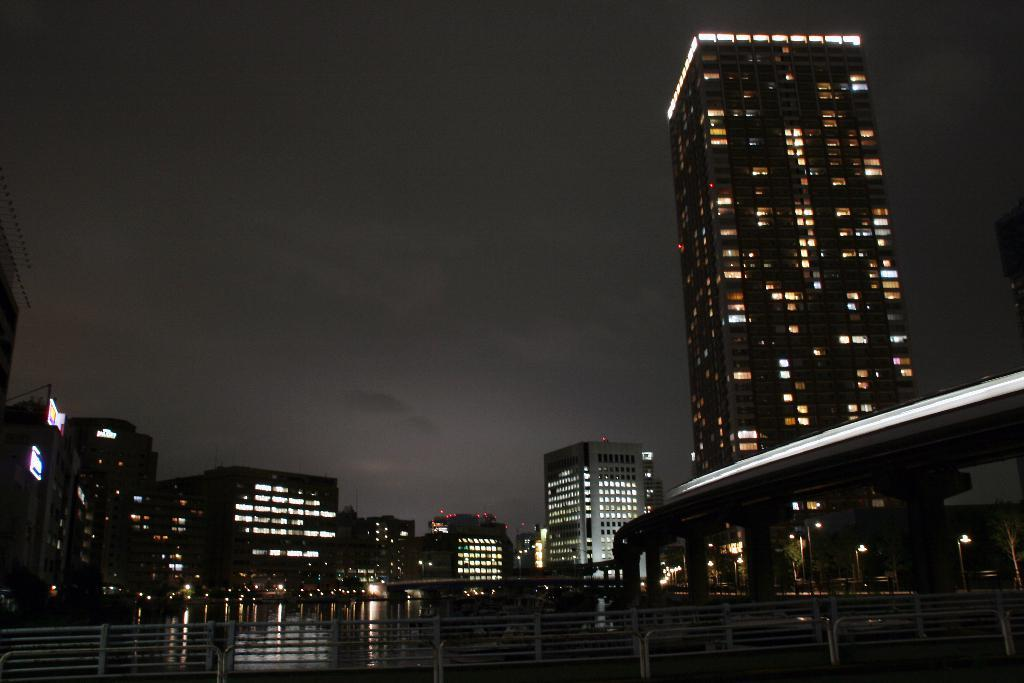What type of structures can be seen in the image? There are buildings in the image. What natural element is visible in the image? There is water visible in the image. What type of illumination is present in the image? There are lights in the image. What type of signage or display can be seen in the image? There are boards in the image. What type of architectural feature is present in the image? There are railings in the image. How would you describe the overall lighting condition in the image? The image appears to be in a dark setting. What type of beetle can be seen crawling on the suit in the image? There is no beetle or suit present in the image. What type of prose is written on the boards in the image? There is no prose written on the boards in the image; they may contain text or images, but not prose. 